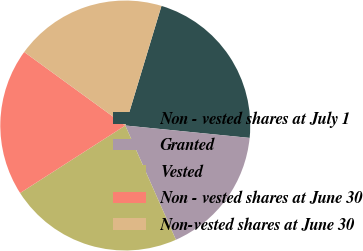Convert chart to OTSL. <chart><loc_0><loc_0><loc_500><loc_500><pie_chart><fcel>Non - vested shares at July 1<fcel>Granted<fcel>Vested<fcel>Non - vested shares at June 30<fcel>Non-vested shares at June 30<nl><fcel>21.91%<fcel>16.78%<fcel>22.56%<fcel>19.09%<fcel>19.67%<nl></chart> 